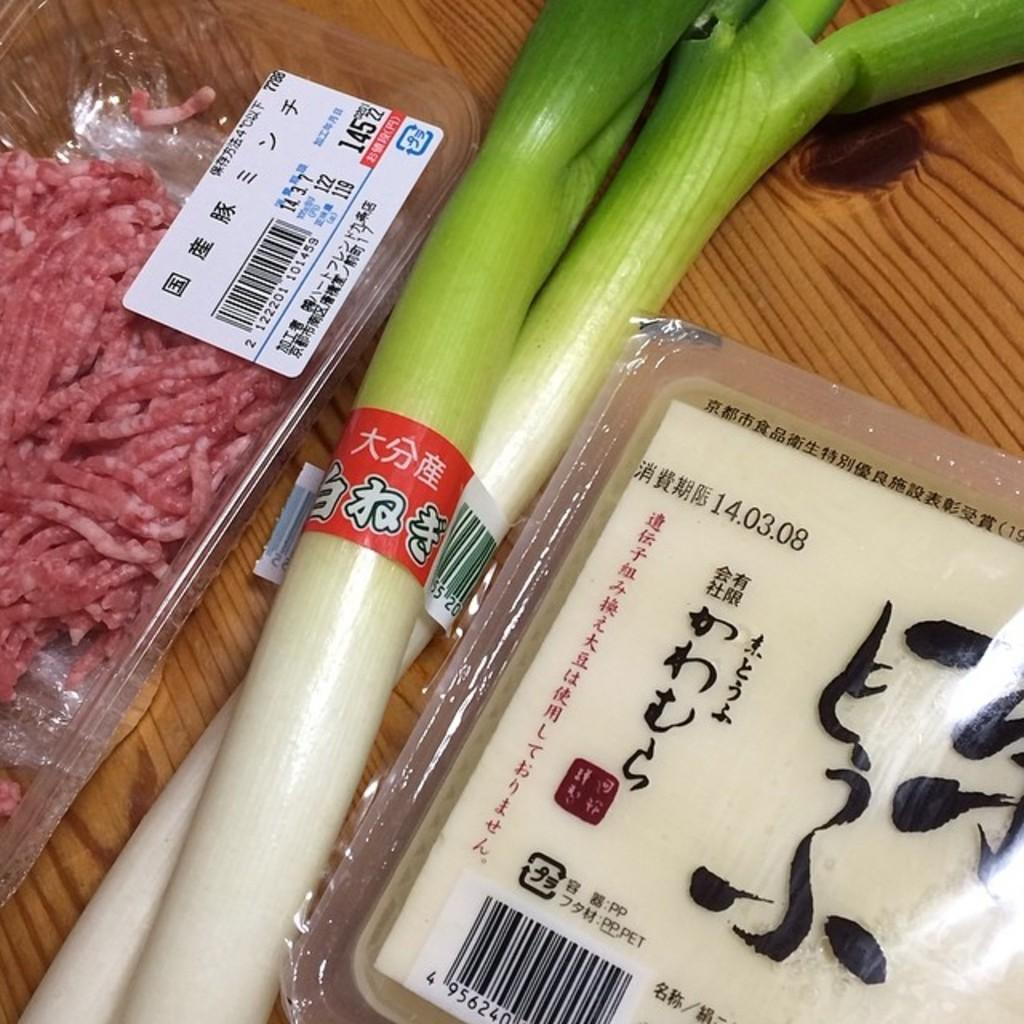How many plastic boxes are visible in the image? There are two plastic boxes in the image. What is inside the plastic boxes? The plastic boxes contain food items. What else can be seen in the image besides the plastic boxes? There are additional food items on a wooden surface. What type of polish is being applied to the skate in the image? There is no skate or polish present in the image; it features two plastic boxes containing food items and additional food items on a wooden surface. 